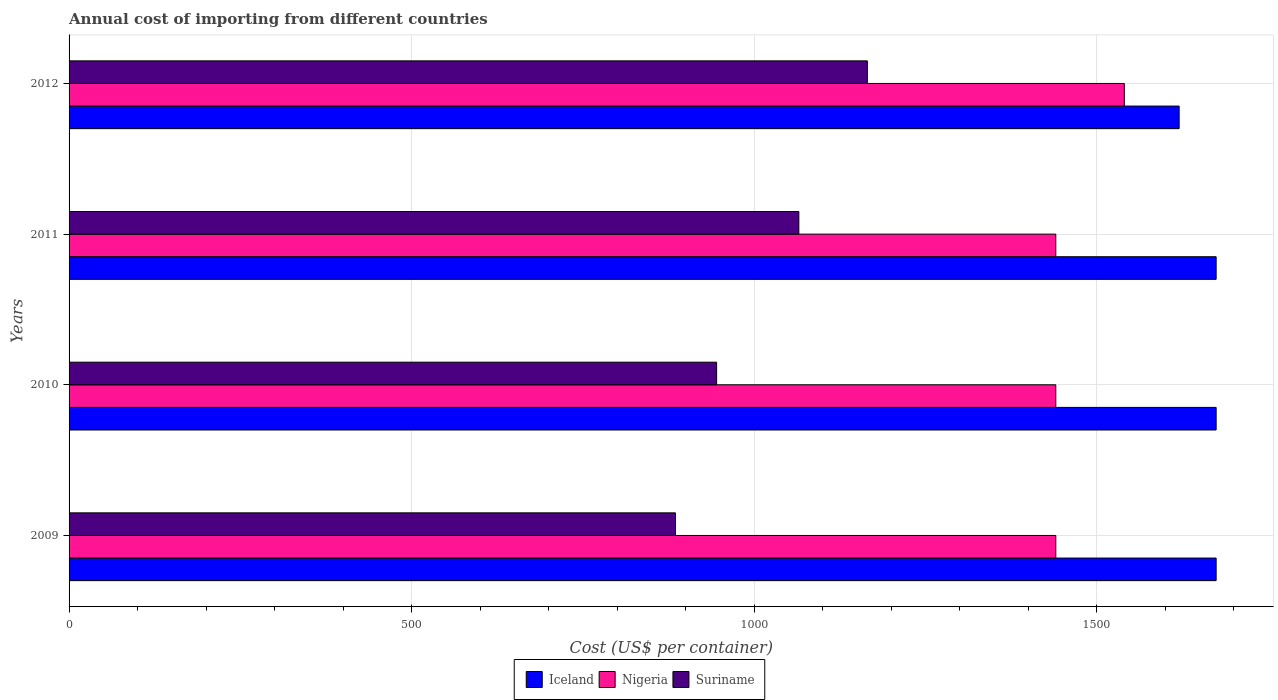Are the number of bars per tick equal to the number of legend labels?
Give a very brief answer. Yes. Are the number of bars on each tick of the Y-axis equal?
Your response must be concise. Yes. How many bars are there on the 4th tick from the top?
Provide a short and direct response. 3. How many bars are there on the 1st tick from the bottom?
Provide a succinct answer. 3. What is the label of the 3rd group of bars from the top?
Provide a short and direct response. 2010. What is the total annual cost of importing in Nigeria in 2011?
Keep it short and to the point. 1440. Across all years, what is the maximum total annual cost of importing in Suriname?
Offer a terse response. 1165. Across all years, what is the minimum total annual cost of importing in Nigeria?
Provide a short and direct response. 1440. What is the total total annual cost of importing in Suriname in the graph?
Offer a terse response. 4060. What is the difference between the total annual cost of importing in Iceland in 2010 and that in 2012?
Your answer should be compact. 54. What is the difference between the total annual cost of importing in Nigeria in 2009 and the total annual cost of importing in Suriname in 2012?
Provide a succinct answer. 275. What is the average total annual cost of importing in Nigeria per year?
Your response must be concise. 1465. What is the ratio of the total annual cost of importing in Suriname in 2010 to that in 2011?
Offer a very short reply. 0.89. Is the difference between the total annual cost of importing in Iceland in 2011 and 2012 greater than the difference between the total annual cost of importing in Nigeria in 2011 and 2012?
Provide a succinct answer. Yes. What is the difference between the highest and the second highest total annual cost of importing in Iceland?
Ensure brevity in your answer.  0. What is the difference between the highest and the lowest total annual cost of importing in Suriname?
Offer a terse response. 280. In how many years, is the total annual cost of importing in Suriname greater than the average total annual cost of importing in Suriname taken over all years?
Offer a very short reply. 2. Is the sum of the total annual cost of importing in Iceland in 2010 and 2011 greater than the maximum total annual cost of importing in Suriname across all years?
Offer a very short reply. Yes. What does the 1st bar from the top in 2009 represents?
Keep it short and to the point. Suriname. What does the 1st bar from the bottom in 2010 represents?
Offer a very short reply. Iceland. How many bars are there?
Offer a very short reply. 12. Are all the bars in the graph horizontal?
Provide a short and direct response. Yes. How many years are there in the graph?
Your answer should be compact. 4. Does the graph contain grids?
Give a very brief answer. Yes. Where does the legend appear in the graph?
Offer a terse response. Bottom center. What is the title of the graph?
Offer a terse response. Annual cost of importing from different countries. Does "United Kingdom" appear as one of the legend labels in the graph?
Give a very brief answer. No. What is the label or title of the X-axis?
Ensure brevity in your answer.  Cost (US$ per container). What is the label or title of the Y-axis?
Offer a very short reply. Years. What is the Cost (US$ per container) in Iceland in 2009?
Ensure brevity in your answer.  1674. What is the Cost (US$ per container) of Nigeria in 2009?
Your answer should be very brief. 1440. What is the Cost (US$ per container) of Suriname in 2009?
Provide a succinct answer. 885. What is the Cost (US$ per container) in Iceland in 2010?
Your response must be concise. 1674. What is the Cost (US$ per container) of Nigeria in 2010?
Keep it short and to the point. 1440. What is the Cost (US$ per container) in Suriname in 2010?
Offer a very short reply. 945. What is the Cost (US$ per container) of Iceland in 2011?
Provide a succinct answer. 1674. What is the Cost (US$ per container) of Nigeria in 2011?
Your response must be concise. 1440. What is the Cost (US$ per container) of Suriname in 2011?
Provide a short and direct response. 1065. What is the Cost (US$ per container) in Iceland in 2012?
Keep it short and to the point. 1620. What is the Cost (US$ per container) in Nigeria in 2012?
Your answer should be very brief. 1540. What is the Cost (US$ per container) of Suriname in 2012?
Offer a very short reply. 1165. Across all years, what is the maximum Cost (US$ per container) in Iceland?
Give a very brief answer. 1674. Across all years, what is the maximum Cost (US$ per container) of Nigeria?
Offer a very short reply. 1540. Across all years, what is the maximum Cost (US$ per container) in Suriname?
Your response must be concise. 1165. Across all years, what is the minimum Cost (US$ per container) of Iceland?
Ensure brevity in your answer.  1620. Across all years, what is the minimum Cost (US$ per container) of Nigeria?
Offer a terse response. 1440. Across all years, what is the minimum Cost (US$ per container) of Suriname?
Offer a very short reply. 885. What is the total Cost (US$ per container) of Iceland in the graph?
Your answer should be compact. 6642. What is the total Cost (US$ per container) of Nigeria in the graph?
Make the answer very short. 5860. What is the total Cost (US$ per container) in Suriname in the graph?
Your response must be concise. 4060. What is the difference between the Cost (US$ per container) in Iceland in 2009 and that in 2010?
Make the answer very short. 0. What is the difference between the Cost (US$ per container) of Nigeria in 2009 and that in 2010?
Give a very brief answer. 0. What is the difference between the Cost (US$ per container) of Suriname in 2009 and that in 2010?
Keep it short and to the point. -60. What is the difference between the Cost (US$ per container) of Nigeria in 2009 and that in 2011?
Keep it short and to the point. 0. What is the difference between the Cost (US$ per container) in Suriname in 2009 and that in 2011?
Make the answer very short. -180. What is the difference between the Cost (US$ per container) in Nigeria in 2009 and that in 2012?
Ensure brevity in your answer.  -100. What is the difference between the Cost (US$ per container) in Suriname in 2009 and that in 2012?
Offer a terse response. -280. What is the difference between the Cost (US$ per container) of Iceland in 2010 and that in 2011?
Offer a terse response. 0. What is the difference between the Cost (US$ per container) of Nigeria in 2010 and that in 2011?
Give a very brief answer. 0. What is the difference between the Cost (US$ per container) of Suriname in 2010 and that in 2011?
Offer a terse response. -120. What is the difference between the Cost (US$ per container) of Iceland in 2010 and that in 2012?
Your answer should be compact. 54. What is the difference between the Cost (US$ per container) of Nigeria in 2010 and that in 2012?
Keep it short and to the point. -100. What is the difference between the Cost (US$ per container) in Suriname in 2010 and that in 2012?
Keep it short and to the point. -220. What is the difference between the Cost (US$ per container) of Iceland in 2011 and that in 2012?
Your response must be concise. 54. What is the difference between the Cost (US$ per container) of Nigeria in 2011 and that in 2012?
Keep it short and to the point. -100. What is the difference between the Cost (US$ per container) of Suriname in 2011 and that in 2012?
Your response must be concise. -100. What is the difference between the Cost (US$ per container) in Iceland in 2009 and the Cost (US$ per container) in Nigeria in 2010?
Ensure brevity in your answer.  234. What is the difference between the Cost (US$ per container) in Iceland in 2009 and the Cost (US$ per container) in Suriname in 2010?
Make the answer very short. 729. What is the difference between the Cost (US$ per container) in Nigeria in 2009 and the Cost (US$ per container) in Suriname in 2010?
Ensure brevity in your answer.  495. What is the difference between the Cost (US$ per container) of Iceland in 2009 and the Cost (US$ per container) of Nigeria in 2011?
Provide a succinct answer. 234. What is the difference between the Cost (US$ per container) in Iceland in 2009 and the Cost (US$ per container) in Suriname in 2011?
Your answer should be very brief. 609. What is the difference between the Cost (US$ per container) in Nigeria in 2009 and the Cost (US$ per container) in Suriname in 2011?
Provide a succinct answer. 375. What is the difference between the Cost (US$ per container) of Iceland in 2009 and the Cost (US$ per container) of Nigeria in 2012?
Offer a very short reply. 134. What is the difference between the Cost (US$ per container) of Iceland in 2009 and the Cost (US$ per container) of Suriname in 2012?
Provide a succinct answer. 509. What is the difference between the Cost (US$ per container) in Nigeria in 2009 and the Cost (US$ per container) in Suriname in 2012?
Your answer should be compact. 275. What is the difference between the Cost (US$ per container) in Iceland in 2010 and the Cost (US$ per container) in Nigeria in 2011?
Give a very brief answer. 234. What is the difference between the Cost (US$ per container) of Iceland in 2010 and the Cost (US$ per container) of Suriname in 2011?
Your answer should be very brief. 609. What is the difference between the Cost (US$ per container) of Nigeria in 2010 and the Cost (US$ per container) of Suriname in 2011?
Provide a succinct answer. 375. What is the difference between the Cost (US$ per container) in Iceland in 2010 and the Cost (US$ per container) in Nigeria in 2012?
Your answer should be very brief. 134. What is the difference between the Cost (US$ per container) in Iceland in 2010 and the Cost (US$ per container) in Suriname in 2012?
Provide a short and direct response. 509. What is the difference between the Cost (US$ per container) in Nigeria in 2010 and the Cost (US$ per container) in Suriname in 2012?
Give a very brief answer. 275. What is the difference between the Cost (US$ per container) in Iceland in 2011 and the Cost (US$ per container) in Nigeria in 2012?
Offer a very short reply. 134. What is the difference between the Cost (US$ per container) of Iceland in 2011 and the Cost (US$ per container) of Suriname in 2012?
Keep it short and to the point. 509. What is the difference between the Cost (US$ per container) in Nigeria in 2011 and the Cost (US$ per container) in Suriname in 2012?
Ensure brevity in your answer.  275. What is the average Cost (US$ per container) in Iceland per year?
Offer a very short reply. 1660.5. What is the average Cost (US$ per container) of Nigeria per year?
Offer a very short reply. 1465. What is the average Cost (US$ per container) in Suriname per year?
Your answer should be very brief. 1015. In the year 2009, what is the difference between the Cost (US$ per container) in Iceland and Cost (US$ per container) in Nigeria?
Your answer should be compact. 234. In the year 2009, what is the difference between the Cost (US$ per container) of Iceland and Cost (US$ per container) of Suriname?
Your response must be concise. 789. In the year 2009, what is the difference between the Cost (US$ per container) of Nigeria and Cost (US$ per container) of Suriname?
Your response must be concise. 555. In the year 2010, what is the difference between the Cost (US$ per container) in Iceland and Cost (US$ per container) in Nigeria?
Make the answer very short. 234. In the year 2010, what is the difference between the Cost (US$ per container) in Iceland and Cost (US$ per container) in Suriname?
Offer a terse response. 729. In the year 2010, what is the difference between the Cost (US$ per container) of Nigeria and Cost (US$ per container) of Suriname?
Keep it short and to the point. 495. In the year 2011, what is the difference between the Cost (US$ per container) in Iceland and Cost (US$ per container) in Nigeria?
Your answer should be very brief. 234. In the year 2011, what is the difference between the Cost (US$ per container) of Iceland and Cost (US$ per container) of Suriname?
Ensure brevity in your answer.  609. In the year 2011, what is the difference between the Cost (US$ per container) of Nigeria and Cost (US$ per container) of Suriname?
Your answer should be compact. 375. In the year 2012, what is the difference between the Cost (US$ per container) of Iceland and Cost (US$ per container) of Nigeria?
Offer a terse response. 80. In the year 2012, what is the difference between the Cost (US$ per container) in Iceland and Cost (US$ per container) in Suriname?
Keep it short and to the point. 455. In the year 2012, what is the difference between the Cost (US$ per container) in Nigeria and Cost (US$ per container) in Suriname?
Provide a succinct answer. 375. What is the ratio of the Cost (US$ per container) of Nigeria in 2009 to that in 2010?
Provide a short and direct response. 1. What is the ratio of the Cost (US$ per container) in Suriname in 2009 to that in 2010?
Provide a short and direct response. 0.94. What is the ratio of the Cost (US$ per container) of Suriname in 2009 to that in 2011?
Ensure brevity in your answer.  0.83. What is the ratio of the Cost (US$ per container) in Nigeria in 2009 to that in 2012?
Give a very brief answer. 0.94. What is the ratio of the Cost (US$ per container) of Suriname in 2009 to that in 2012?
Provide a succinct answer. 0.76. What is the ratio of the Cost (US$ per container) of Iceland in 2010 to that in 2011?
Give a very brief answer. 1. What is the ratio of the Cost (US$ per container) of Suriname in 2010 to that in 2011?
Provide a short and direct response. 0.89. What is the ratio of the Cost (US$ per container) of Nigeria in 2010 to that in 2012?
Give a very brief answer. 0.94. What is the ratio of the Cost (US$ per container) in Suriname in 2010 to that in 2012?
Offer a terse response. 0.81. What is the ratio of the Cost (US$ per container) in Iceland in 2011 to that in 2012?
Provide a succinct answer. 1.03. What is the ratio of the Cost (US$ per container) of Nigeria in 2011 to that in 2012?
Keep it short and to the point. 0.94. What is the ratio of the Cost (US$ per container) in Suriname in 2011 to that in 2012?
Make the answer very short. 0.91. What is the difference between the highest and the second highest Cost (US$ per container) of Iceland?
Your response must be concise. 0. What is the difference between the highest and the second highest Cost (US$ per container) of Nigeria?
Your response must be concise. 100. What is the difference between the highest and the second highest Cost (US$ per container) in Suriname?
Offer a very short reply. 100. What is the difference between the highest and the lowest Cost (US$ per container) in Suriname?
Give a very brief answer. 280. 